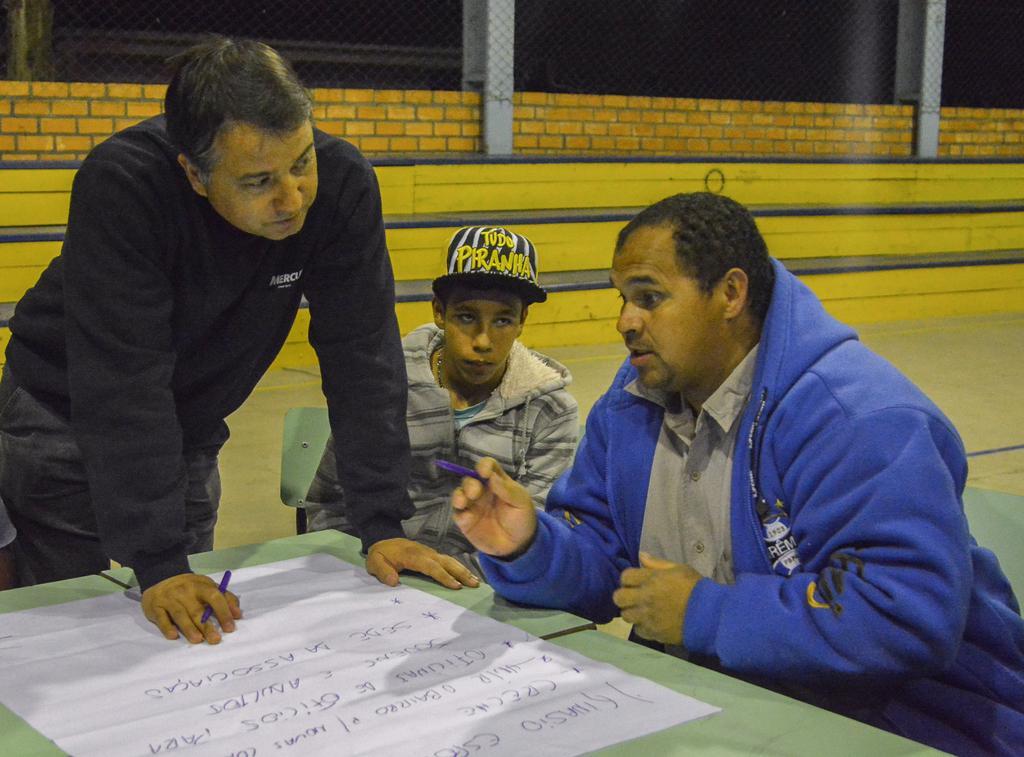How would you summarize this image in a sentence or two? In this image there is a paper on the table, a person standing and holding a pen , two persons sitting on the chairs, and in the background there is wire fence. 